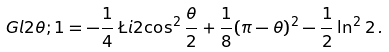<formula> <loc_0><loc_0><loc_500><loc_500>\ G l { 2 } { \theta ; 1 } = - \frac { 1 } { 4 } \, \L i { 2 } { \cos ^ { 2 } { \frac { \theta } { 2 } } } + \frac { 1 } { 8 } ( \pi - \theta ) ^ { 2 } - \frac { 1 } { 2 } \ln ^ { 2 } { 2 } \, .</formula> 